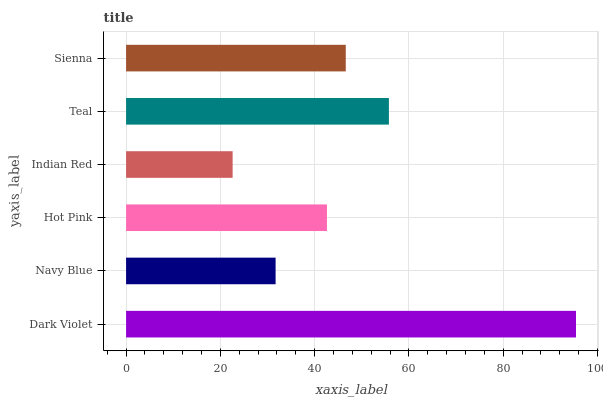Is Indian Red the minimum?
Answer yes or no. Yes. Is Dark Violet the maximum?
Answer yes or no. Yes. Is Navy Blue the minimum?
Answer yes or no. No. Is Navy Blue the maximum?
Answer yes or no. No. Is Dark Violet greater than Navy Blue?
Answer yes or no. Yes. Is Navy Blue less than Dark Violet?
Answer yes or no. Yes. Is Navy Blue greater than Dark Violet?
Answer yes or no. No. Is Dark Violet less than Navy Blue?
Answer yes or no. No. Is Sienna the high median?
Answer yes or no. Yes. Is Hot Pink the low median?
Answer yes or no. Yes. Is Hot Pink the high median?
Answer yes or no. No. Is Indian Red the low median?
Answer yes or no. No. 